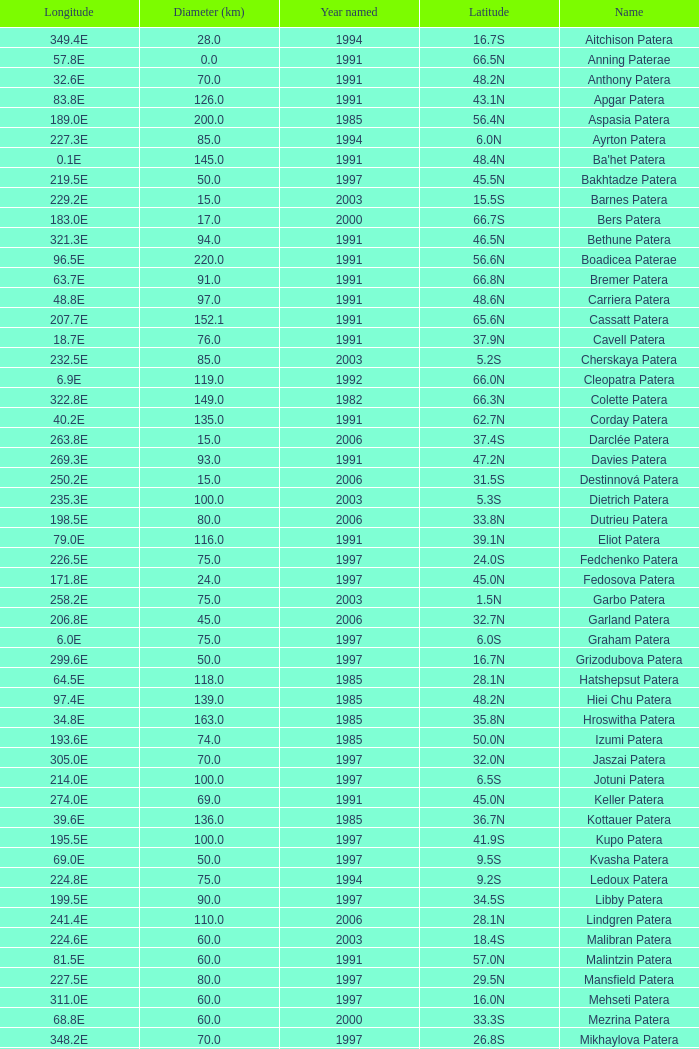What is Longitude, when Name is Raskova Paterae? 222.8E. 